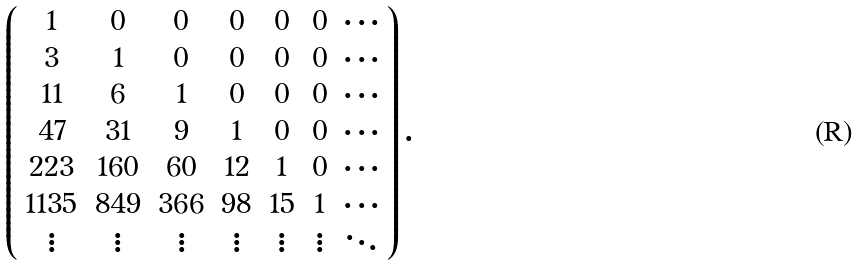Convert formula to latex. <formula><loc_0><loc_0><loc_500><loc_500>\left ( \begin{array} { c c c c c c c } 1 & 0 & 0 & 0 & 0 & 0 & \cdots \\ 3 & 1 & 0 & 0 & 0 & 0 & \cdots \\ 1 1 & 6 & 1 & 0 & 0 & 0 & \cdots \\ 4 7 & 3 1 & 9 & 1 & 0 & 0 & \cdots \\ 2 2 3 & 1 6 0 & 6 0 & 1 2 & 1 & 0 & \cdots \\ 1 1 3 5 & 8 4 9 & 3 6 6 & 9 8 & 1 5 & 1 & \cdots \\ \vdots & \vdots & \vdots & \vdots & \vdots & \vdots & \ddots \end{array} \right ) .</formula> 